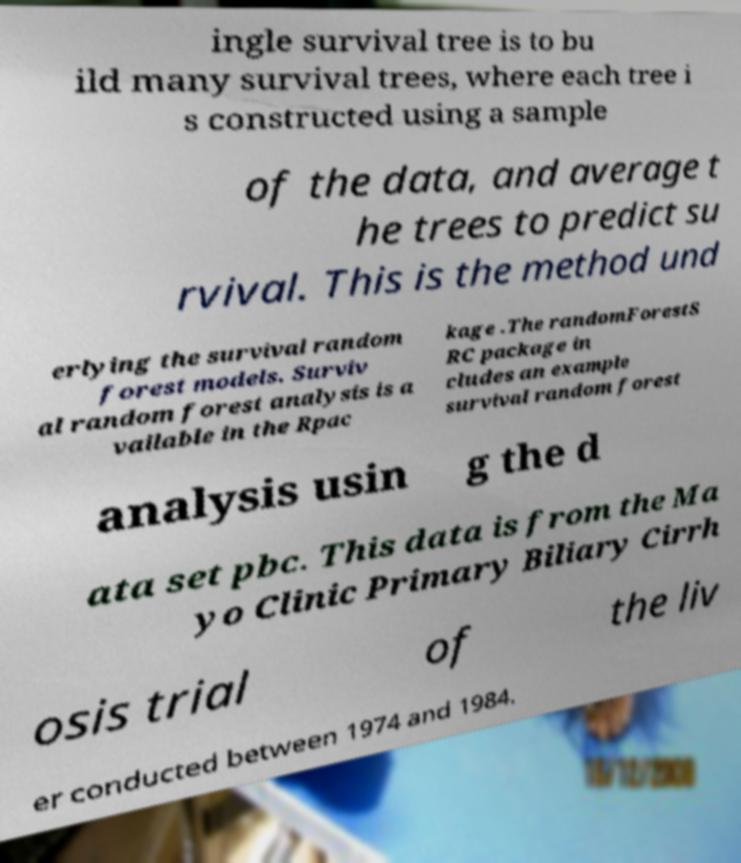Please identify and transcribe the text found in this image. ingle survival tree is to bu ild many survival trees, where each tree i s constructed using a sample of the data, and average t he trees to predict su rvival. This is the method und erlying the survival random forest models. Surviv al random forest analysis is a vailable in the Rpac kage .The randomForestS RC package in cludes an example survival random forest analysis usin g the d ata set pbc. This data is from the Ma yo Clinic Primary Biliary Cirrh osis trial of the liv er conducted between 1974 and 1984. 